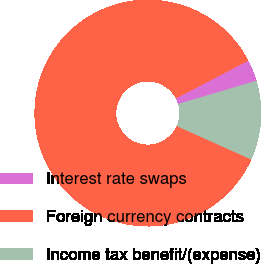<chart> <loc_0><loc_0><loc_500><loc_500><pie_chart><fcel>Interest rate swaps<fcel>Foreign currency contracts<fcel>Income tax benefit/(expense)<nl><fcel>3.06%<fcel>85.63%<fcel>11.31%<nl></chart> 